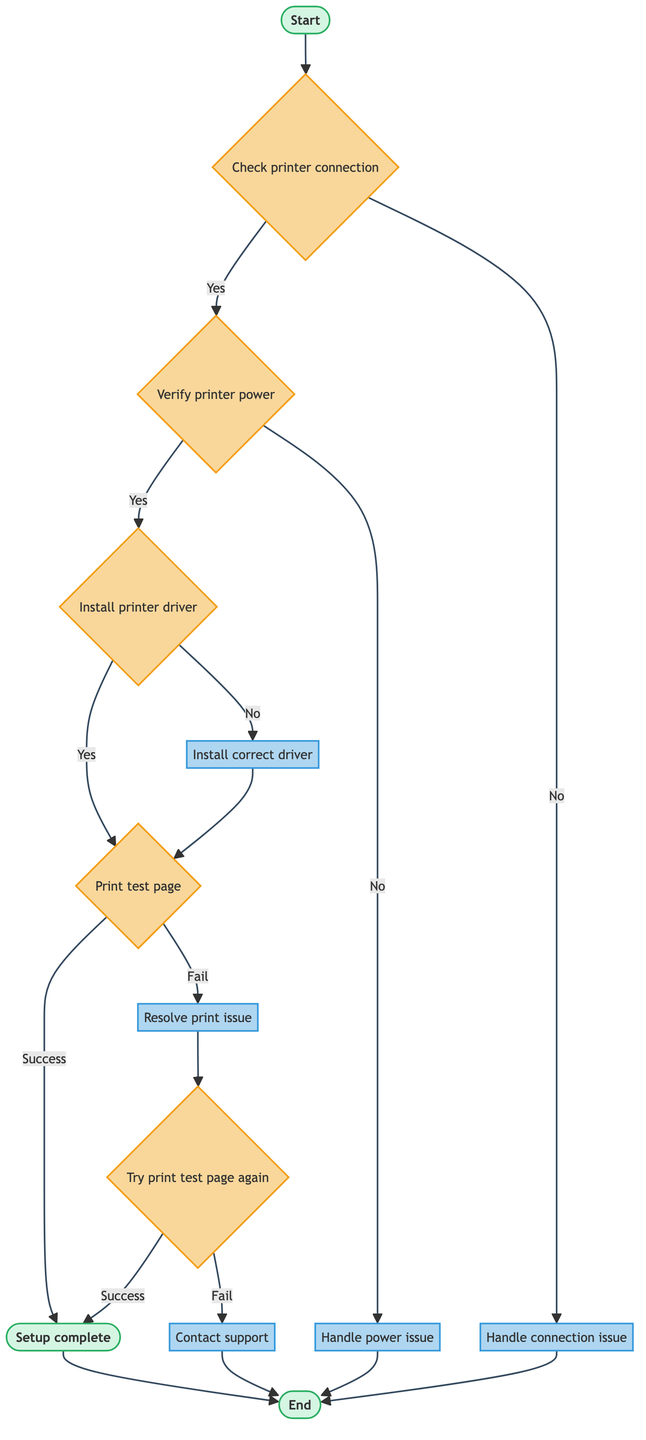What's the first step in the process? The first step in the process is "Check printer connection," which is indicated after the start node.
Answer: Check printer connection How many action nodes are in the diagram? Upon counting, there are five action nodes: "Install correct driver," "Resolve print issue," "Handle connection issue," "Handle power issue," and "Contact support."
Answer: Five What node follows the "Verify printer power" condition if the answer is 'No'? If the answer is 'No' to "Verify printer power," it leads to the node "Handle power issue," which is shown in the diagram.
Answer: Handle power issue What happens if the "Print test page" step fails? If the "Print test page" step fails, the next step is to "Resolve print issue," as indicated by the flow from that node.
Answer: Resolve print issue What occurs after the "Install correct driver" action? After the "Install correct driver" action, the next step is to "Print test page," which directly follows it in the flowchart.
Answer: Print test page If both attempts of "Try print test page again" fail, what should the user do? If both attempts of "Try print test page again" fail, the user should "Contact support," as indicated by the flow from that condition.
Answer: Contact support What node leads to "Setup complete" from "Install printer driver"? From "Install printer driver," if successful, the next node is "Print test page," which leads to "Setup complete" if that also succeeds.
Answer: Print test page What is the outcome of solving common print issues? The outcome of solving common print issues is that the user attempts to "Try print test page again," which is the next step if issues are resolved.
Answer: Try print test page again Which node is connected to "End" after handling connection issues? The node "Handle connection issue" leads directly to the "End" node, as indicated in the diagram.
Answer: Handle connection issue 